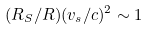Convert formula to latex. <formula><loc_0><loc_0><loc_500><loc_500>( R _ { S } / R ) ( v _ { s } / c ) ^ { 2 } \sim 1</formula> 